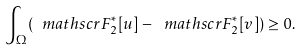<formula> <loc_0><loc_0><loc_500><loc_500>\int _ { \Omega } ( \ m a t h s c r { F } _ { 2 } ^ { * } [ u ] - \ m a t h s c r { F } _ { 2 } ^ { * } [ v ] ) \geq 0 .</formula> 